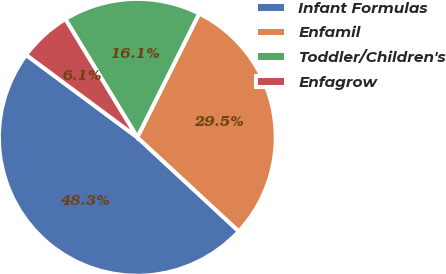<chart> <loc_0><loc_0><loc_500><loc_500><pie_chart><fcel>Infant Formulas<fcel>Enfamil<fcel>Toddler/Children's<fcel>Enfagrow<nl><fcel>48.27%<fcel>29.51%<fcel>16.08%<fcel>6.15%<nl></chart> 